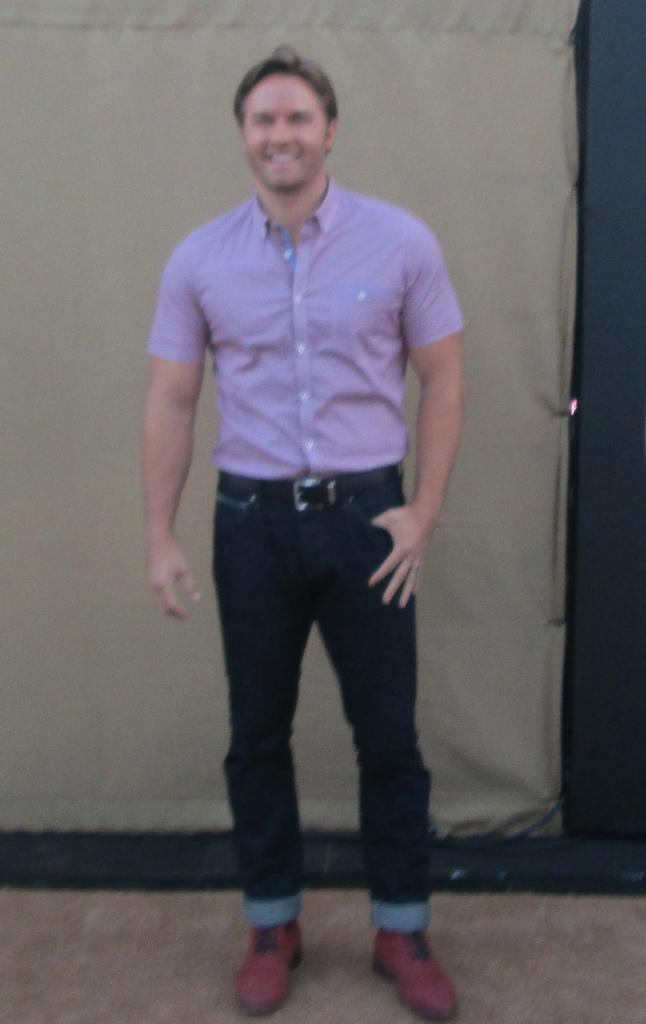Who is present in the image? There is a man in the image. What can be seen in the background of the image? There is a wall in the background of the image. What type of mist can be seen surrounding the man in the image? There is no mist present in the image; it only features a man and a wall in the background. 